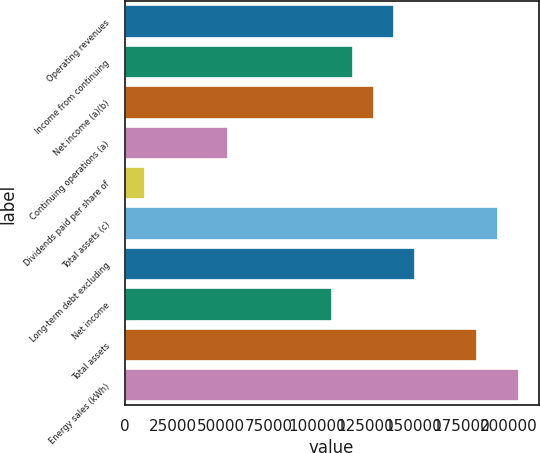Convert chart to OTSL. <chart><loc_0><loc_0><loc_500><loc_500><bar_chart><fcel>Operating revenues<fcel>Income from continuing<fcel>Net income (a)(b)<fcel>Continuing operations (a)<fcel>Dividends paid per share of<fcel>Total assets (c)<fcel>Long-term debt excluding<fcel>Net income<fcel>Total assets<fcel>Energy sales (kWh)<nl><fcel>140371<fcel>118776<fcel>129573<fcel>53989.4<fcel>10798.5<fcel>194360<fcel>151169<fcel>107978<fcel>183562<fcel>205157<nl></chart> 